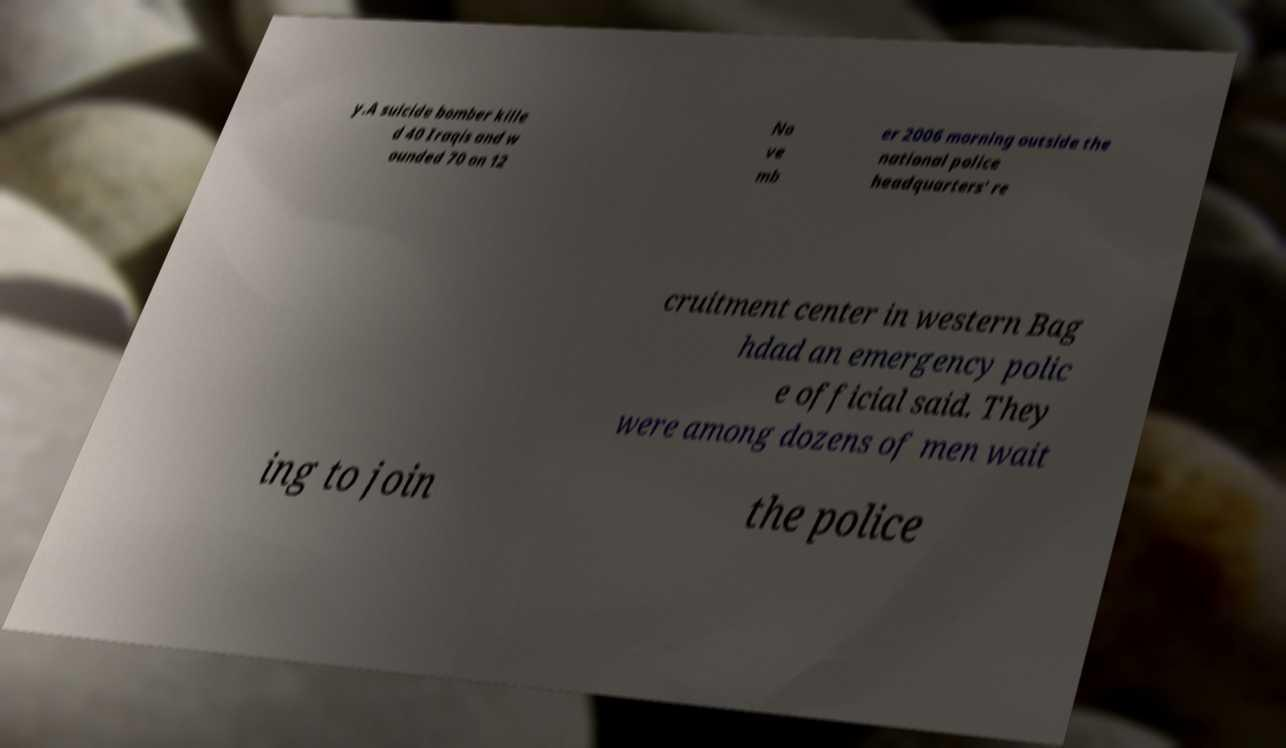Can you read and provide the text displayed in the image?This photo seems to have some interesting text. Can you extract and type it out for me? y.A suicide bomber kille d 40 Iraqis and w ounded 70 on 12 No ve mb er 2006 morning outside the national police headquarters' re cruitment center in western Bag hdad an emergency polic e official said. They were among dozens of men wait ing to join the police 